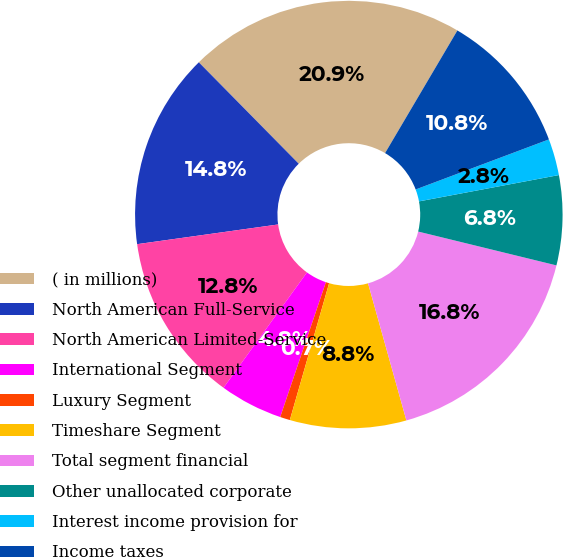Convert chart. <chart><loc_0><loc_0><loc_500><loc_500><pie_chart><fcel>( in millions)<fcel>North American Full-Service<fcel>North American Limited-Service<fcel>International Segment<fcel>Luxury Segment<fcel>Timeshare Segment<fcel>Total segment financial<fcel>Other unallocated corporate<fcel>Interest income provision for<fcel>Income taxes<nl><fcel>20.86%<fcel>14.83%<fcel>12.82%<fcel>4.77%<fcel>0.75%<fcel>8.79%<fcel>16.84%<fcel>6.78%<fcel>2.76%<fcel>10.8%<nl></chart> 